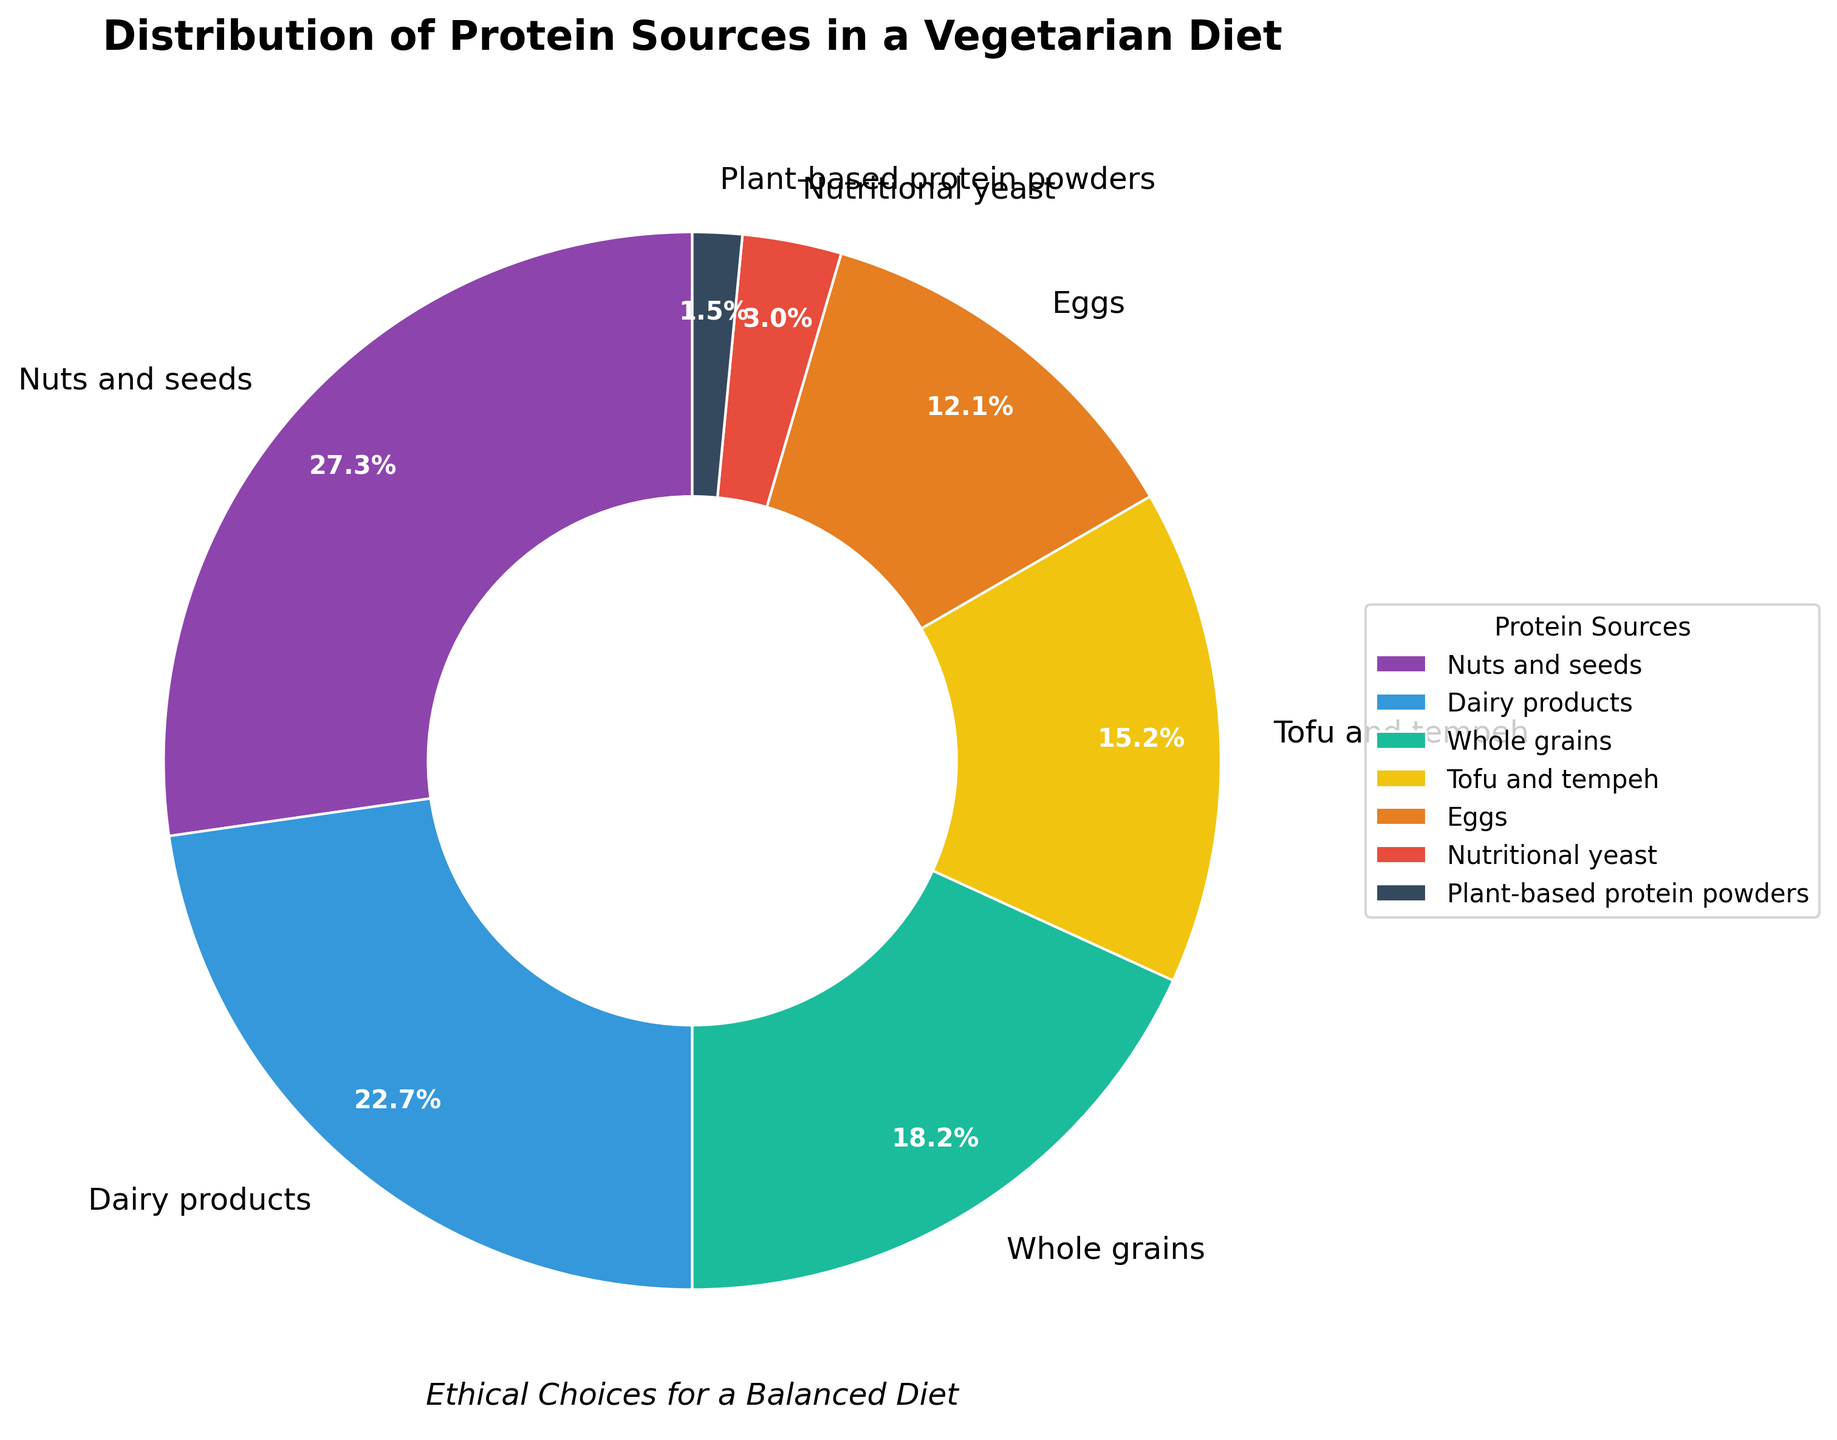1. Which protein source has the highest percentage in a vegetarian diet? By looking at the pie chart, the segment representing "Nuts and seeds" is the largest, indicating it has the highest percentage.
Answer: Nuts and seeds 2. What is the combined percentage of protein from Tofu and tempeh and Eggs? By summing the percentages: Tofu and tempeh (10%) + Eggs (8%) = 18%.
Answer: 18% 3. Is the percentage of protein from Whole grains greater than the percentage from Dairy products? Whole grains have 12%, while Dairy products have 15%. 12% is not greater than 15%.
Answer: No 4. What is the percentage difference between Dairy products and Nuts and seeds? Subtract Dairy products' percentage from Nuts and seeds' percentage: 18% - 15% = 3%.
Answer: 3% 5. Which protein sources contribute less than 5% to the total protein intake? The segments for "Nutritional yeast" (2%) and "Plant-based protein powders" (1%) are below 5%.
Answer: Nutritional yeast, Plant-based protein powders 6. In terms of visual representation, which color is used to represent Whole grains? Whole grains are associated with the third color in the legend, which is green.
Answer: Green 7. What is the total percentage of protein from sources other than Dairy products and Nuts and seeds? Subtract the percentages of Nuts and seeds (18%) and Dairy (15%) from 100%: 100% - 18% - 15% = 67%.
Answer: 67% 8. If you group plant-based sources (Nuts and seeds, Whole grains, Tofu and tempeh, Nutritional yeast, Plant-based protein powders), what is the total percentage contribution? Sum the percentages: Nuts and seeds (18%) + Whole grains (12%) + Tofu and tempeh (10%) + Nutritional yeast (2%) + Plant-based protein powders (1%) = 43%.
Answer: 43% 9. How many protein sources are displayed in the figure? By counting the segments in the pie chart, there are seven protein sources listed.
Answer: Seven 10. Which source is represented by the red section of the pie chart? The red section, located fifth in the legend, represents Eggs.
Answer: Eggs 